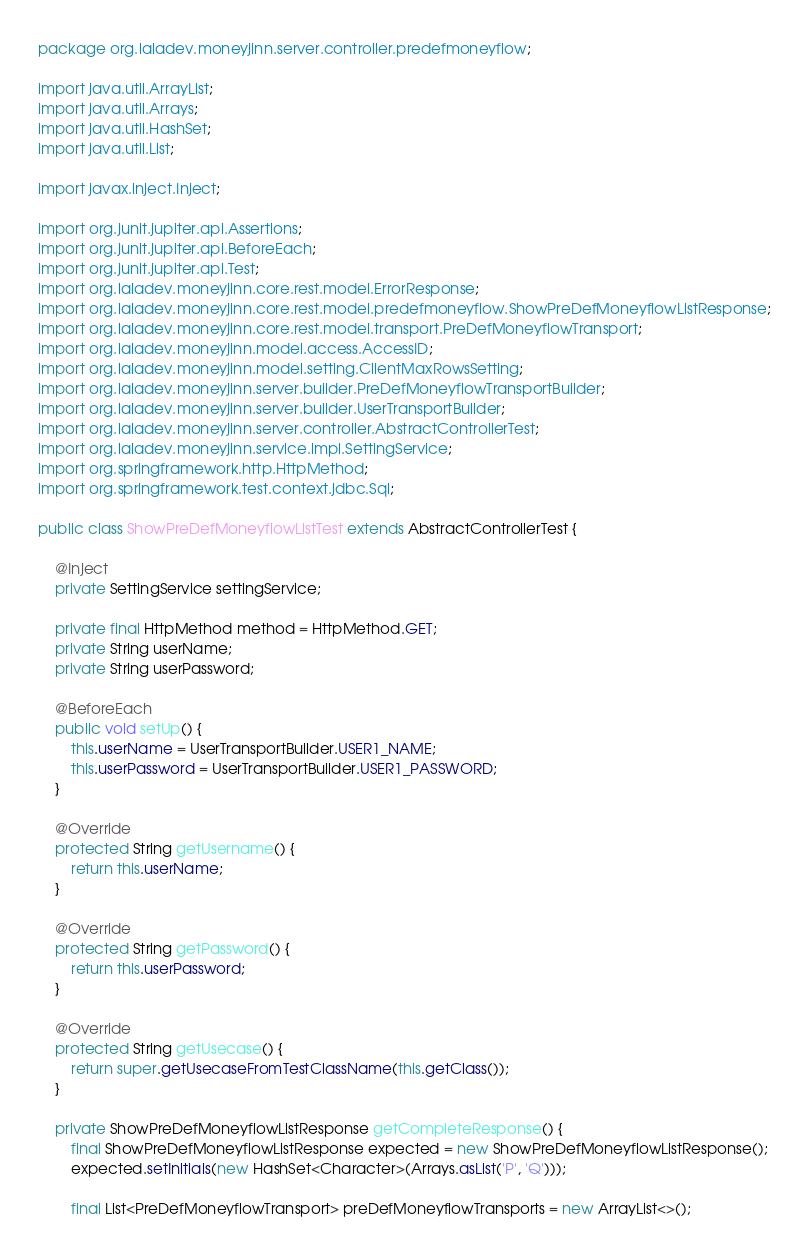<code> <loc_0><loc_0><loc_500><loc_500><_Java_>package org.laladev.moneyjinn.server.controller.predefmoneyflow;

import java.util.ArrayList;
import java.util.Arrays;
import java.util.HashSet;
import java.util.List;

import javax.inject.Inject;

import org.junit.jupiter.api.Assertions;
import org.junit.jupiter.api.BeforeEach;
import org.junit.jupiter.api.Test;
import org.laladev.moneyjinn.core.rest.model.ErrorResponse;
import org.laladev.moneyjinn.core.rest.model.predefmoneyflow.ShowPreDefMoneyflowListResponse;
import org.laladev.moneyjinn.core.rest.model.transport.PreDefMoneyflowTransport;
import org.laladev.moneyjinn.model.access.AccessID;
import org.laladev.moneyjinn.model.setting.ClientMaxRowsSetting;
import org.laladev.moneyjinn.server.builder.PreDefMoneyflowTransportBuilder;
import org.laladev.moneyjinn.server.builder.UserTransportBuilder;
import org.laladev.moneyjinn.server.controller.AbstractControllerTest;
import org.laladev.moneyjinn.service.impl.SettingService;
import org.springframework.http.HttpMethod;
import org.springframework.test.context.jdbc.Sql;

public class ShowPreDefMoneyflowListTest extends AbstractControllerTest {

	@Inject
	private SettingService settingService;

	private final HttpMethod method = HttpMethod.GET;
	private String userName;
	private String userPassword;

	@BeforeEach
	public void setUp() {
		this.userName = UserTransportBuilder.USER1_NAME;
		this.userPassword = UserTransportBuilder.USER1_PASSWORD;
	}

	@Override
	protected String getUsername() {
		return this.userName;
	}

	@Override
	protected String getPassword() {
		return this.userPassword;
	}

	@Override
	protected String getUsecase() {
		return super.getUsecaseFromTestClassName(this.getClass());
	}

	private ShowPreDefMoneyflowListResponse getCompleteResponse() {
		final ShowPreDefMoneyflowListResponse expected = new ShowPreDefMoneyflowListResponse();
		expected.setInitials(new HashSet<Character>(Arrays.asList('P', 'Q')));

		final List<PreDefMoneyflowTransport> preDefMoneyflowTransports = new ArrayList<>();</code> 